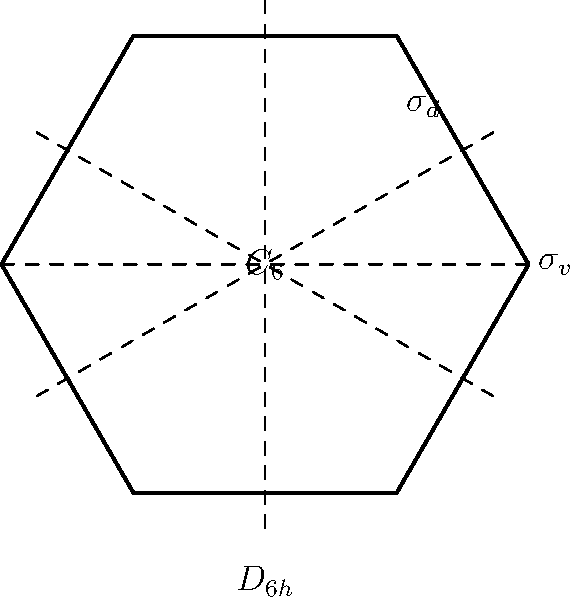In the context of abstract algebra applied to architectural design, consider the symmetry group $D_{6h}$ shown in the diagram. How does this group's structure contribute to the structural integrity of a hexagonal building, and what potential advantages could this offer for innovative startup technologies in construction? To answer this question, let's break down the analysis step-by-step:

1. Symmetry Group Identification:
   The diagram shows the symmetry elements of the $D_{6h}$ group, which includes:
   - A 6-fold rotational symmetry ($C_6$)
   - 6 reflection planes: 3 vertical ($\sigma_v$) and 3 diagonal ($\sigma_d$)

2. Structural Implications:
   a) Rotational Symmetry:
      - The $C_6$ symmetry ensures equal distribution of forces in all directions.
      - This reduces weak points and stress concentrations.

   b) Reflection Symmetry:
      - The $\sigma_v$ and $\sigma_d$ planes create a balanced distribution of mass.
      - This symmetry helps in evenly distributing loads across the structure.

3. Advantages for Structural Integrity:
   - Uniform stress distribution leads to better load-bearing capacity.
   - Reduced likelihood of structural failure due to symmetrical design.
   - Improved stability against lateral forces (e.g., wind, seismic activity).

4. Innovative Startup Technologies:
   a) Modular Construction:
      - The symmetry allows for standardized, repeatable components.
      - This can lead to more efficient prefabrication and assembly processes.

   b) Optimized Material Usage:
      - The balanced design can minimize material waste.
      - AI algorithms can leverage this symmetry for optimal material distribution.

   c) Energy Efficiency:
      - Symmetrical designs often have better thermal and acoustic properties.
      - This can be exploited for creating energy-efficient building envelopes.

   d) Scalability:
      - The principles of $D_{6h}$ symmetry can be applied at various scales.
      - This allows for consistent structural integrity from small to large constructions.

5. Abstract Algebra Application:
   - Group theory can be used to analyze and predict structural behavior.
   - Symmetry operations can be represented as matrices, allowing for computational modeling and analysis.

By leveraging the $D_{6h}$ symmetry group, startups can develop innovative construction technologies that combine structural integrity with efficiency and sustainability, aligning well with the interests of a forward-thinking venture capitalist.
Answer: $D_{6h}$ symmetry enhances structural integrity through uniform load distribution, enabling innovative construction technologies focused on modularity, material optimization, energy efficiency, and scalability. 